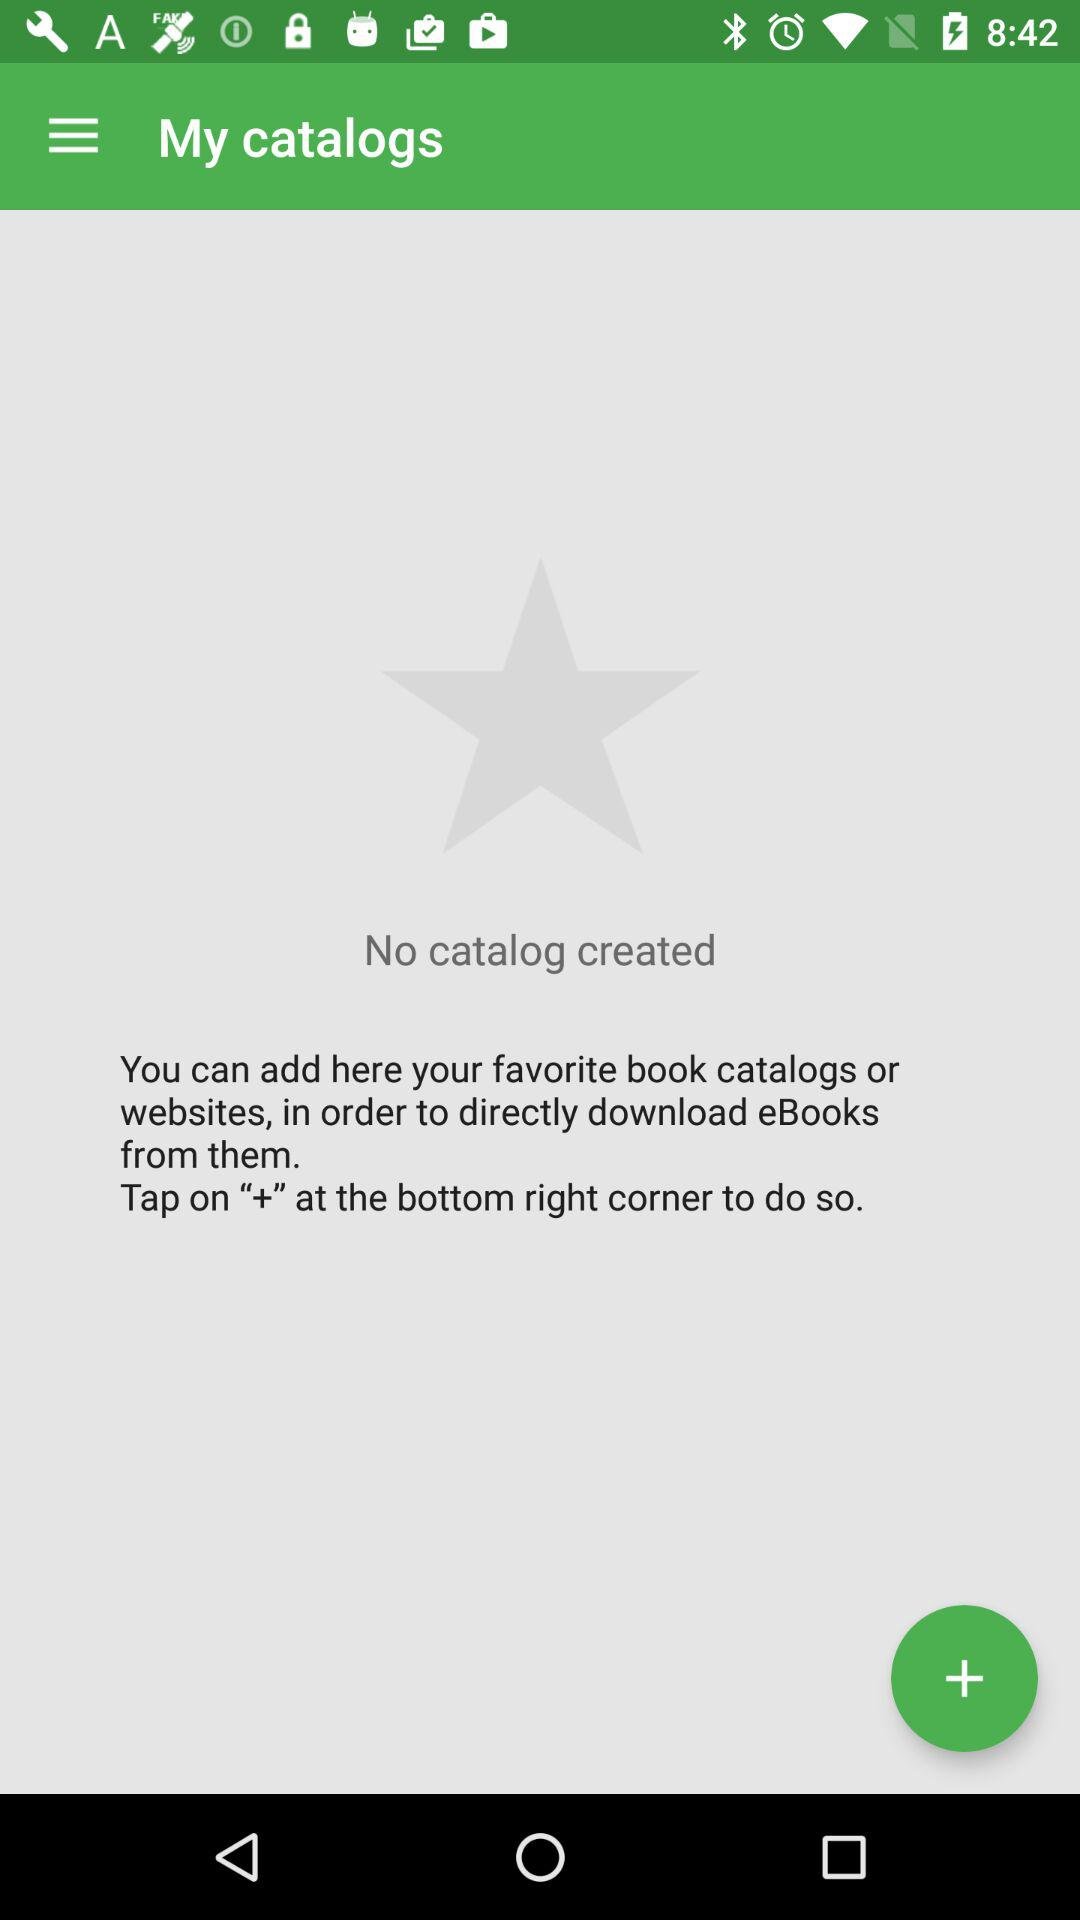How many catalogs have been created?
Answer the question using a single word or phrase. 0 